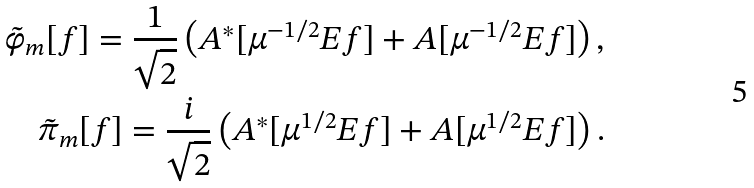Convert formula to latex. <formula><loc_0><loc_0><loc_500><loc_500>\tilde { \varphi } _ { m } [ f ] = \frac { 1 } { \sqrt { 2 } } \left ( A ^ { * } [ \mu ^ { - 1 / 2 } E f ] + A [ \mu ^ { - 1 / 2 } E f ] \right ) , \\ \tilde { \pi } _ { m } [ f ] = \frac { i } { \sqrt { 2 } } \left ( A ^ { * } [ \mu ^ { 1 / 2 } E f ] + A [ \mu ^ { 1 / 2 } E f ] \right ) .</formula> 